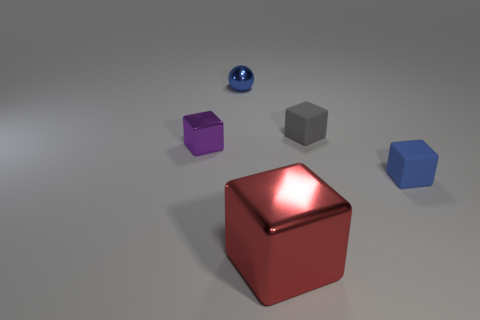There is a small matte object that is the same color as the ball; what shape is it?
Your response must be concise. Cube. There is a red thing that is the same shape as the blue matte thing; what material is it?
Offer a very short reply. Metal. Does the large red thing have the same material as the tiny blue object on the right side of the big metallic thing?
Provide a succinct answer. No. What number of objects are either objects right of the tiny blue metallic object or tiny matte cubes behind the small blue matte block?
Your answer should be compact. 3. What shape is the thing that is both in front of the small metallic block and left of the tiny gray block?
Keep it short and to the point. Cube. There is a small matte thing behind the blue rubber block; how many objects are in front of it?
Your response must be concise. 3. There is a blue matte object right of the tiny blue metallic sphere; what is its size?
Make the answer very short. Small. There is a metal object to the right of the blue ball that is behind the big red metallic block; what is its shape?
Make the answer very short. Cube. There is a small sphere; is its color the same as the block that is in front of the blue matte thing?
Your answer should be compact. No. The thing that is the same color as the tiny sphere is what size?
Provide a short and direct response. Small. 